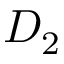Convert formula to latex. <formula><loc_0><loc_0><loc_500><loc_500>D _ { 2 }</formula> 